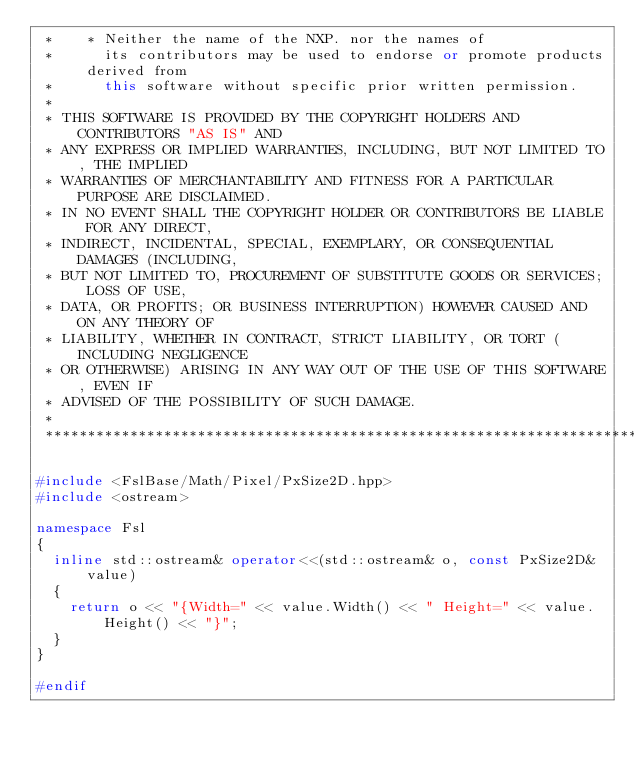Convert code to text. <code><loc_0><loc_0><loc_500><loc_500><_C++_> *    * Neither the name of the NXP. nor the names of
 *      its contributors may be used to endorse or promote products derived from
 *      this software without specific prior written permission.
 *
 * THIS SOFTWARE IS PROVIDED BY THE COPYRIGHT HOLDERS AND CONTRIBUTORS "AS IS" AND
 * ANY EXPRESS OR IMPLIED WARRANTIES, INCLUDING, BUT NOT LIMITED TO, THE IMPLIED
 * WARRANTIES OF MERCHANTABILITY AND FITNESS FOR A PARTICULAR PURPOSE ARE DISCLAIMED.
 * IN NO EVENT SHALL THE COPYRIGHT HOLDER OR CONTRIBUTORS BE LIABLE FOR ANY DIRECT,
 * INDIRECT, INCIDENTAL, SPECIAL, EXEMPLARY, OR CONSEQUENTIAL DAMAGES (INCLUDING,
 * BUT NOT LIMITED TO, PROCUREMENT OF SUBSTITUTE GOODS OR SERVICES; LOSS OF USE,
 * DATA, OR PROFITS; OR BUSINESS INTERRUPTION) HOWEVER CAUSED AND ON ANY THEORY OF
 * LIABILITY, WHETHER IN CONTRACT, STRICT LIABILITY, OR TORT (INCLUDING NEGLIGENCE
 * OR OTHERWISE) ARISING IN ANY WAY OUT OF THE USE OF THIS SOFTWARE, EVEN IF
 * ADVISED OF THE POSSIBILITY OF SUCH DAMAGE.
 *
 ****************************************************************************************************************************************************/

#include <FslBase/Math/Pixel/PxSize2D.hpp>
#include <ostream>

namespace Fsl
{
  inline std::ostream& operator<<(std::ostream& o, const PxSize2D& value)
  {
    return o << "{Width=" << value.Width() << " Height=" << value.Height() << "}";
  }
}

#endif
</code> 